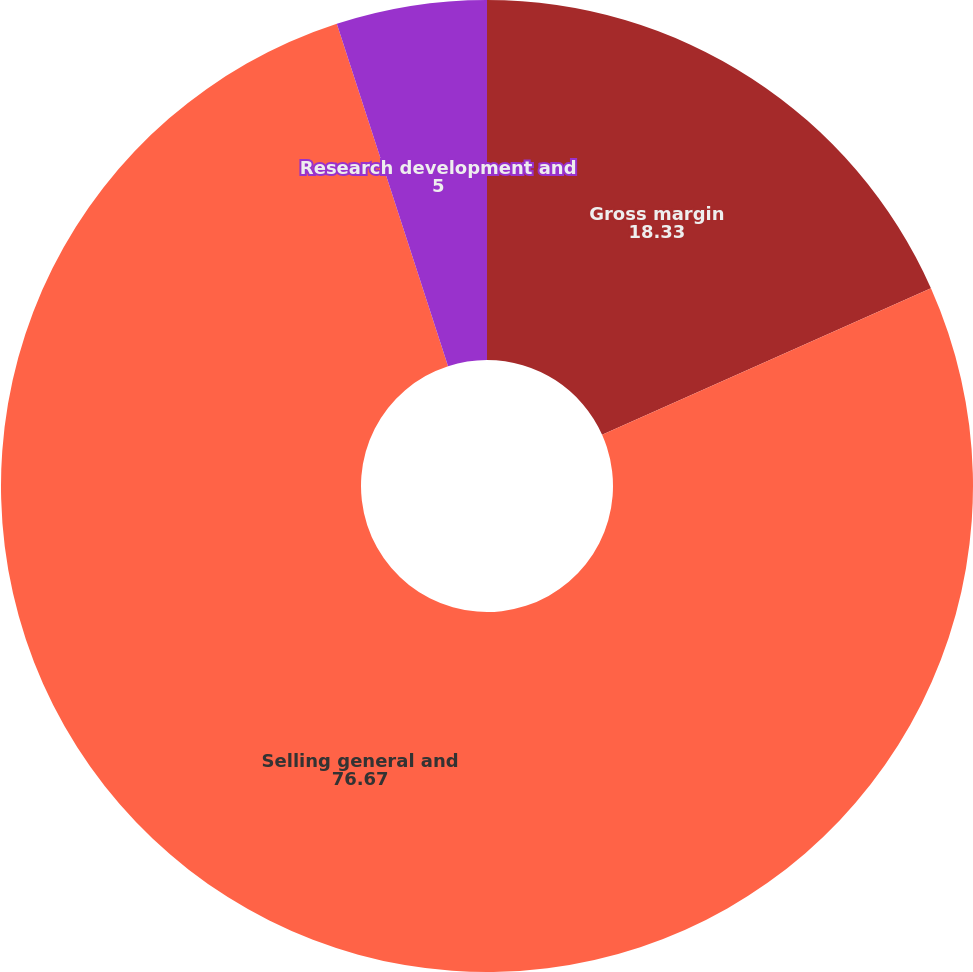<chart> <loc_0><loc_0><loc_500><loc_500><pie_chart><fcel>Gross margin<fcel>Selling general and<fcel>Research development and<nl><fcel>18.33%<fcel>76.67%<fcel>5.0%<nl></chart> 